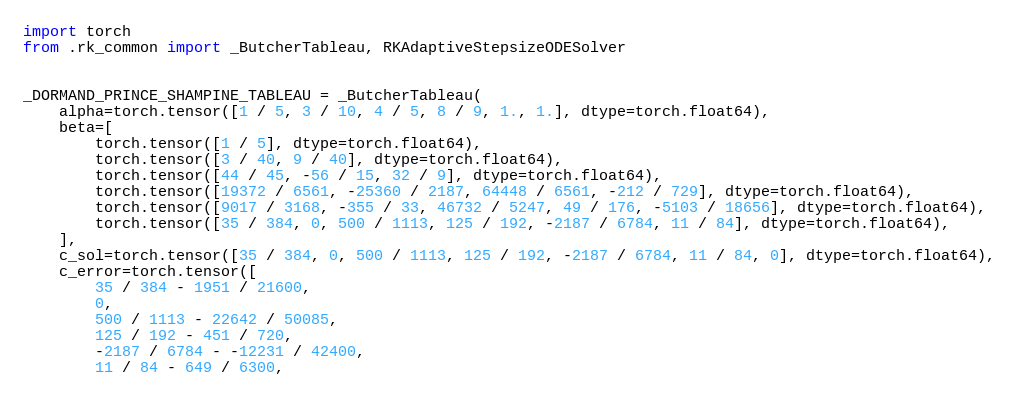<code> <loc_0><loc_0><loc_500><loc_500><_Python_>import torch
from .rk_common import _ButcherTableau, RKAdaptiveStepsizeODESolver


_DORMAND_PRINCE_SHAMPINE_TABLEAU = _ButcherTableau(
    alpha=torch.tensor([1 / 5, 3 / 10, 4 / 5, 8 / 9, 1., 1.], dtype=torch.float64),
    beta=[
        torch.tensor([1 / 5], dtype=torch.float64),
        torch.tensor([3 / 40, 9 / 40], dtype=torch.float64),
        torch.tensor([44 / 45, -56 / 15, 32 / 9], dtype=torch.float64),
        torch.tensor([19372 / 6561, -25360 / 2187, 64448 / 6561, -212 / 729], dtype=torch.float64),
        torch.tensor([9017 / 3168, -355 / 33, 46732 / 5247, 49 / 176, -5103 / 18656], dtype=torch.float64),
        torch.tensor([35 / 384, 0, 500 / 1113, 125 / 192, -2187 / 6784, 11 / 84], dtype=torch.float64),
    ],
    c_sol=torch.tensor([35 / 384, 0, 500 / 1113, 125 / 192, -2187 / 6784, 11 / 84, 0], dtype=torch.float64),
    c_error=torch.tensor([
        35 / 384 - 1951 / 21600,
        0,
        500 / 1113 - 22642 / 50085,
        125 / 192 - 451 / 720,
        -2187 / 6784 - -12231 / 42400,
        11 / 84 - 649 / 6300,</code> 